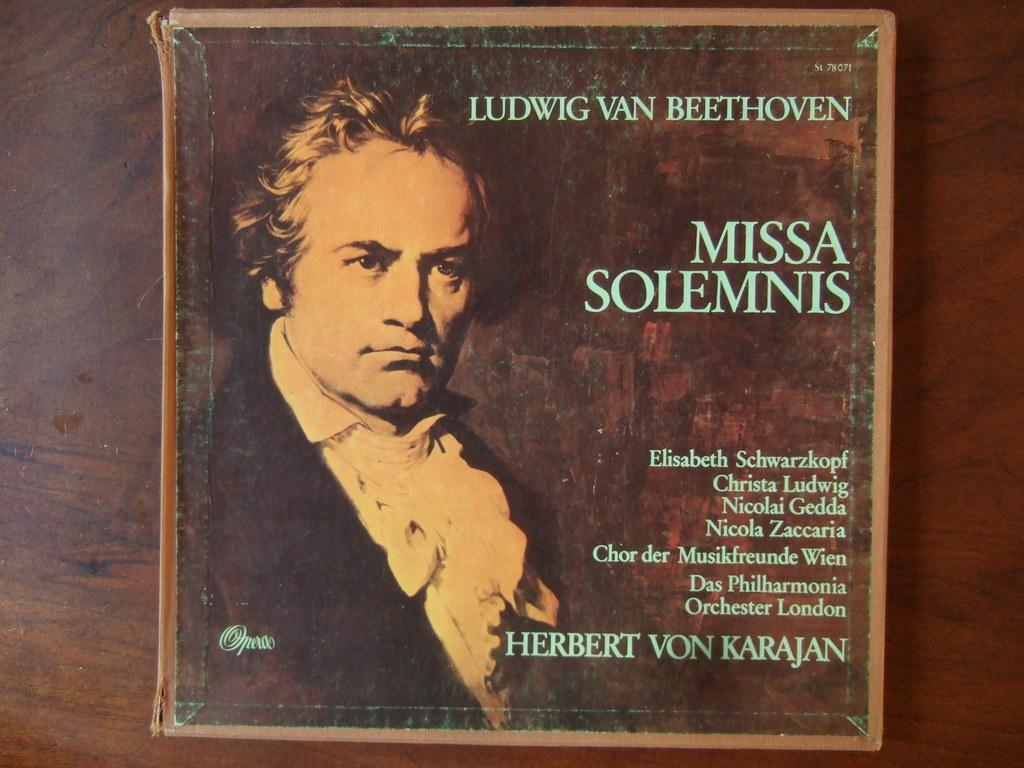What is the main subject in the center of the image? There is a book in the center of the image. What is depicted on the book? There is a person on the book. What can be found on the book besides the person? There is text on the book. What type of furniture is visible in the background of the image? There is a wooden table in the background of the image. What type of branch is the person holding in the image? There is no branch present in the image; the person is depicted on the book. What ornament is hanging from the person's neck in the image? There is no ornament visible in the image; the person is simply depicted on the book. 